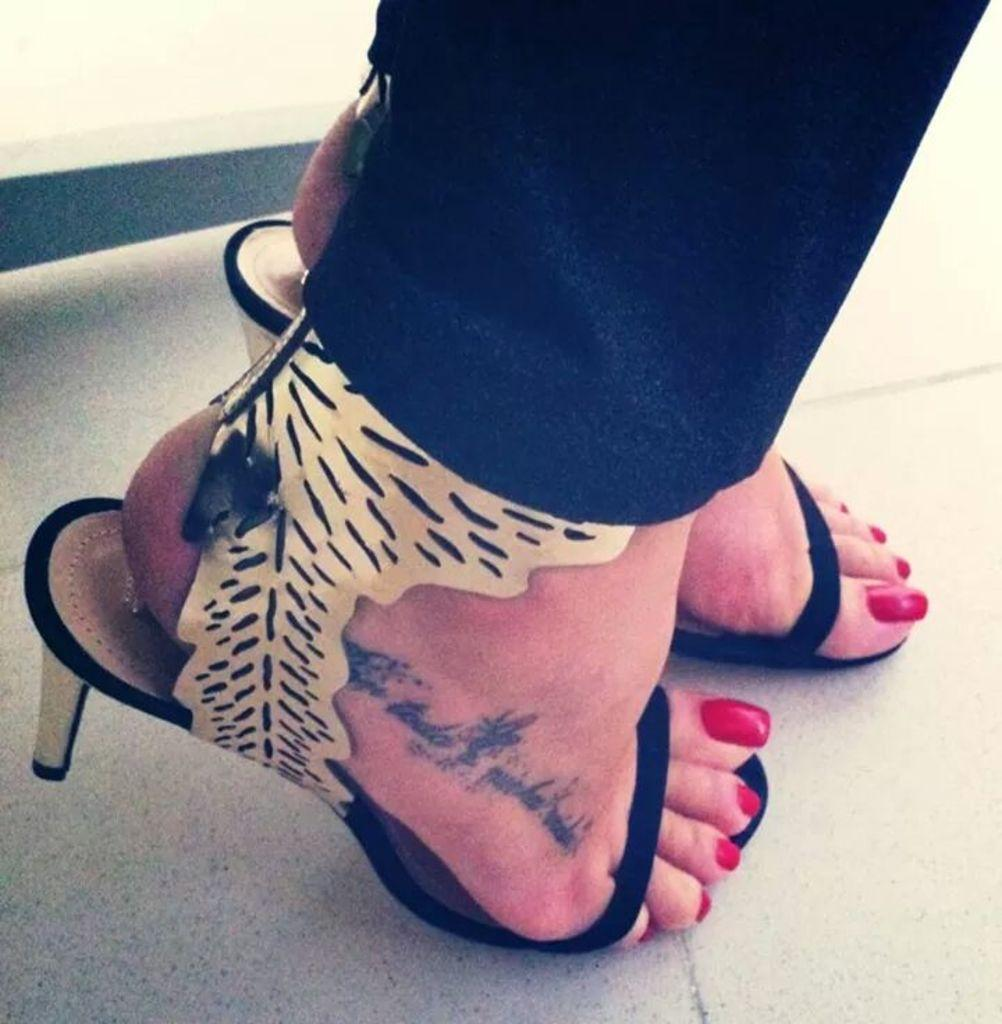What part of the human body that can be seen in the image? Human legs are visible in the image. What are the legs wearing? The legs are wearing clothes and sandals. What type of surface is visible in the image? The image shows a floor. How many jellyfish can be seen swimming on the floor in the image? There are no jellyfish present in the image; it only shows human legs wearing clothes and sandals on a floor. 